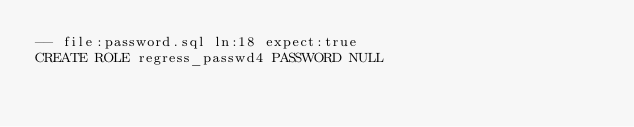<code> <loc_0><loc_0><loc_500><loc_500><_SQL_>-- file:password.sql ln:18 expect:true
CREATE ROLE regress_passwd4 PASSWORD NULL
</code> 